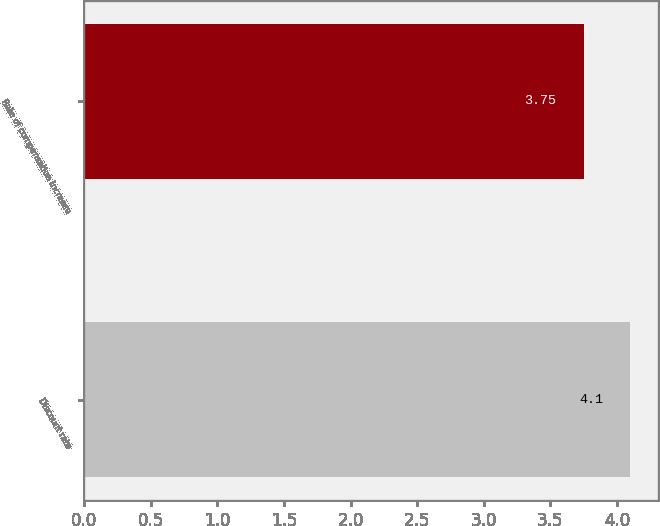<chart> <loc_0><loc_0><loc_500><loc_500><bar_chart><fcel>Discount rate<fcel>Rate of compensation increase<nl><fcel>4.1<fcel>3.75<nl></chart> 